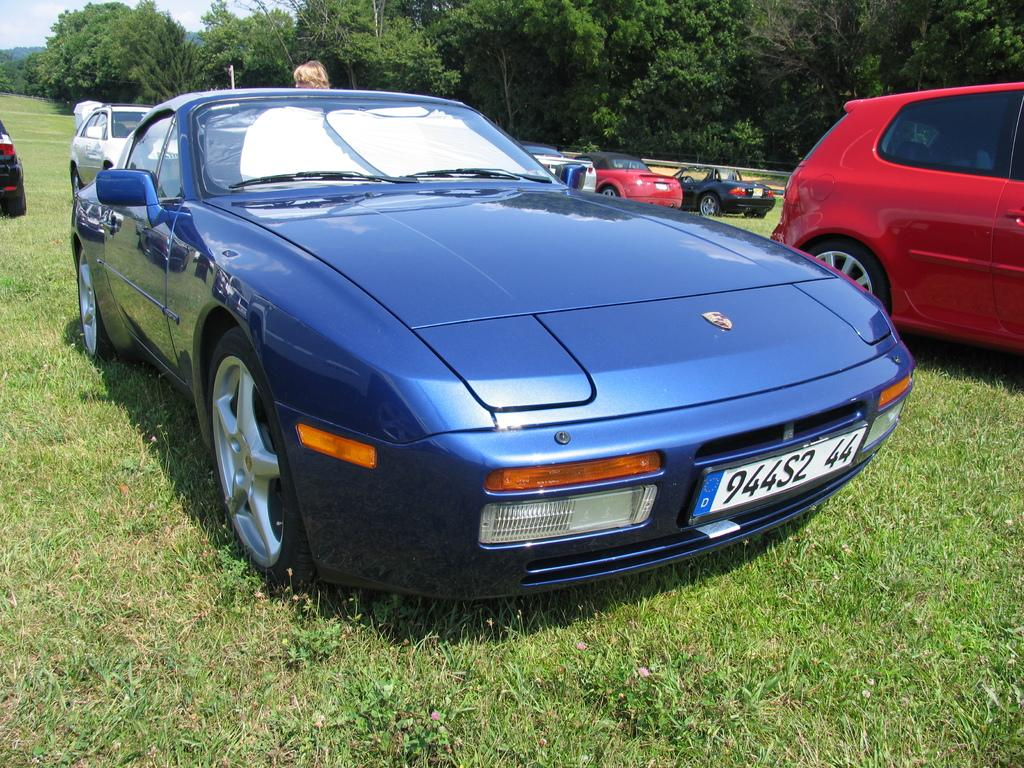What type of vehicles can be seen in the image? There are cars in the image. What is the ground surface like in the image? There is grass on the ground in the image. What type of natural elements are visible in the image? There are trees visible in the image. What part of the natural environment is visible in the image? The sky is visible in the image. What type of bells can be heard ringing in the image? There are no bells present in the image, and therefore no sound can be heard. 